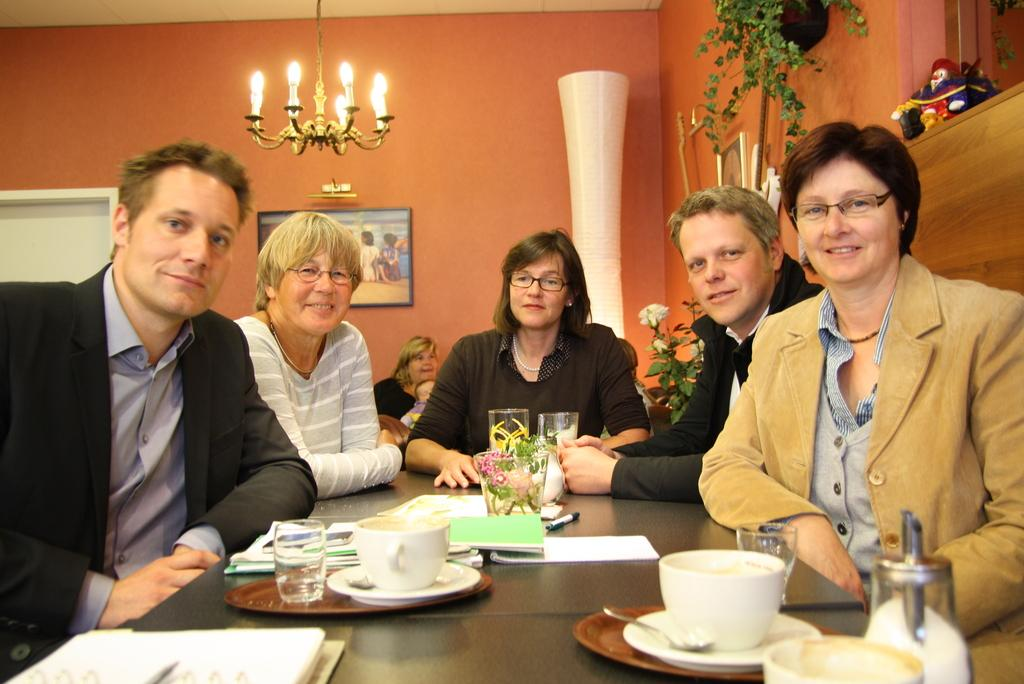What is happening in the image? There is a group of people in the image, and they are seated. What objects are on the table in the image? There are cups and glasses on the table in the image. What time of day is it in the image? The time of day cannot be determined from the image, as there are no clues or indicators present. 